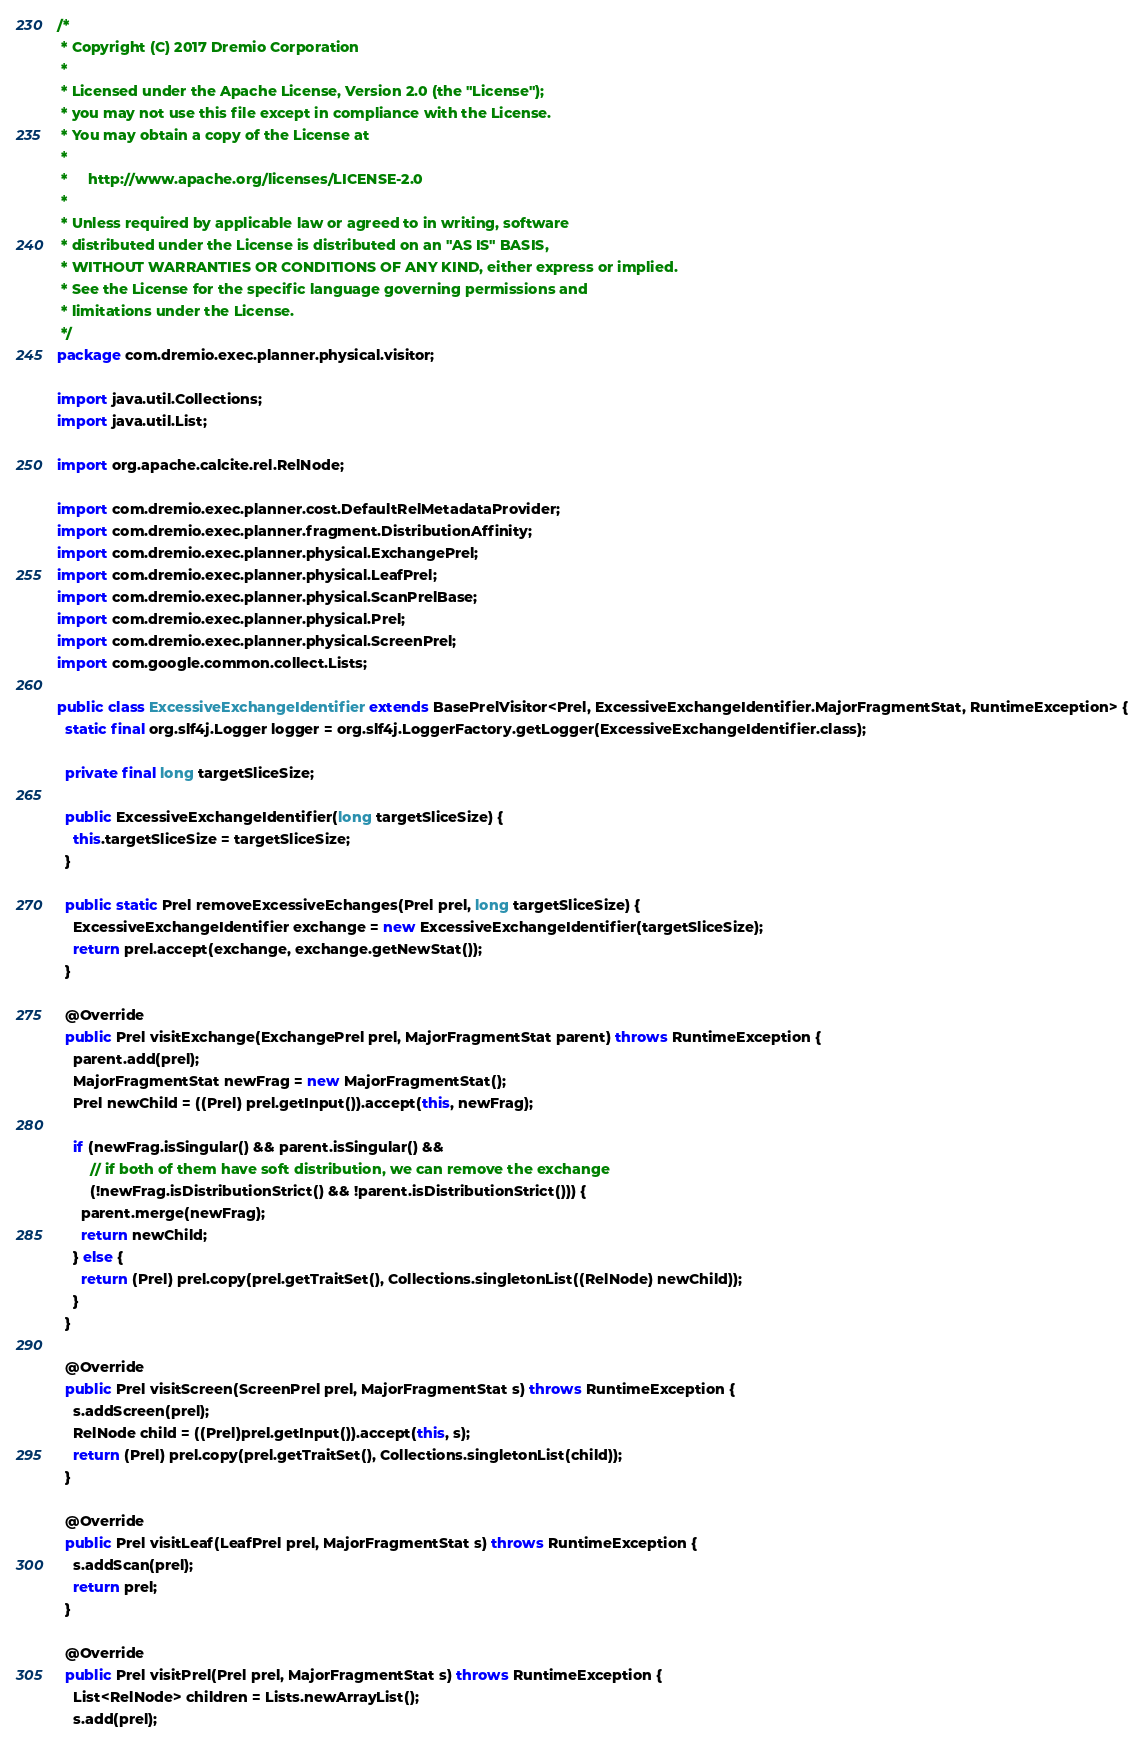Convert code to text. <code><loc_0><loc_0><loc_500><loc_500><_Java_>/*
 * Copyright (C) 2017 Dremio Corporation
 *
 * Licensed under the Apache License, Version 2.0 (the "License");
 * you may not use this file except in compliance with the License.
 * You may obtain a copy of the License at
 *
 *     http://www.apache.org/licenses/LICENSE-2.0
 *
 * Unless required by applicable law or agreed to in writing, software
 * distributed under the License is distributed on an "AS IS" BASIS,
 * WITHOUT WARRANTIES OR CONDITIONS OF ANY KIND, either express or implied.
 * See the License for the specific language governing permissions and
 * limitations under the License.
 */
package com.dremio.exec.planner.physical.visitor;

import java.util.Collections;
import java.util.List;

import org.apache.calcite.rel.RelNode;

import com.dremio.exec.planner.cost.DefaultRelMetadataProvider;
import com.dremio.exec.planner.fragment.DistributionAffinity;
import com.dremio.exec.planner.physical.ExchangePrel;
import com.dremio.exec.planner.physical.LeafPrel;
import com.dremio.exec.planner.physical.ScanPrelBase;
import com.dremio.exec.planner.physical.Prel;
import com.dremio.exec.planner.physical.ScreenPrel;
import com.google.common.collect.Lists;

public class ExcessiveExchangeIdentifier extends BasePrelVisitor<Prel, ExcessiveExchangeIdentifier.MajorFragmentStat, RuntimeException> {
  static final org.slf4j.Logger logger = org.slf4j.LoggerFactory.getLogger(ExcessiveExchangeIdentifier.class);

  private final long targetSliceSize;

  public ExcessiveExchangeIdentifier(long targetSliceSize) {
    this.targetSliceSize = targetSliceSize;
  }

  public static Prel removeExcessiveEchanges(Prel prel, long targetSliceSize) {
    ExcessiveExchangeIdentifier exchange = new ExcessiveExchangeIdentifier(targetSliceSize);
    return prel.accept(exchange, exchange.getNewStat());
  }

  @Override
  public Prel visitExchange(ExchangePrel prel, MajorFragmentStat parent) throws RuntimeException {
    parent.add(prel);
    MajorFragmentStat newFrag = new MajorFragmentStat();
    Prel newChild = ((Prel) prel.getInput()).accept(this, newFrag);

    if (newFrag.isSingular() && parent.isSingular() &&
        // if both of them have soft distribution, we can remove the exchange
        (!newFrag.isDistributionStrict() && !parent.isDistributionStrict())) {
      parent.merge(newFrag);
      return newChild;
    } else {
      return (Prel) prel.copy(prel.getTraitSet(), Collections.singletonList((RelNode) newChild));
    }
  }

  @Override
  public Prel visitScreen(ScreenPrel prel, MajorFragmentStat s) throws RuntimeException {
    s.addScreen(prel);
    RelNode child = ((Prel)prel.getInput()).accept(this, s);
    return (Prel) prel.copy(prel.getTraitSet(), Collections.singletonList(child));
  }

  @Override
  public Prel visitLeaf(LeafPrel prel, MajorFragmentStat s) throws RuntimeException {
    s.addScan(prel);
    return prel;
  }

  @Override
  public Prel visitPrel(Prel prel, MajorFragmentStat s) throws RuntimeException {
    List<RelNode> children = Lists.newArrayList();
    s.add(prel);
</code> 